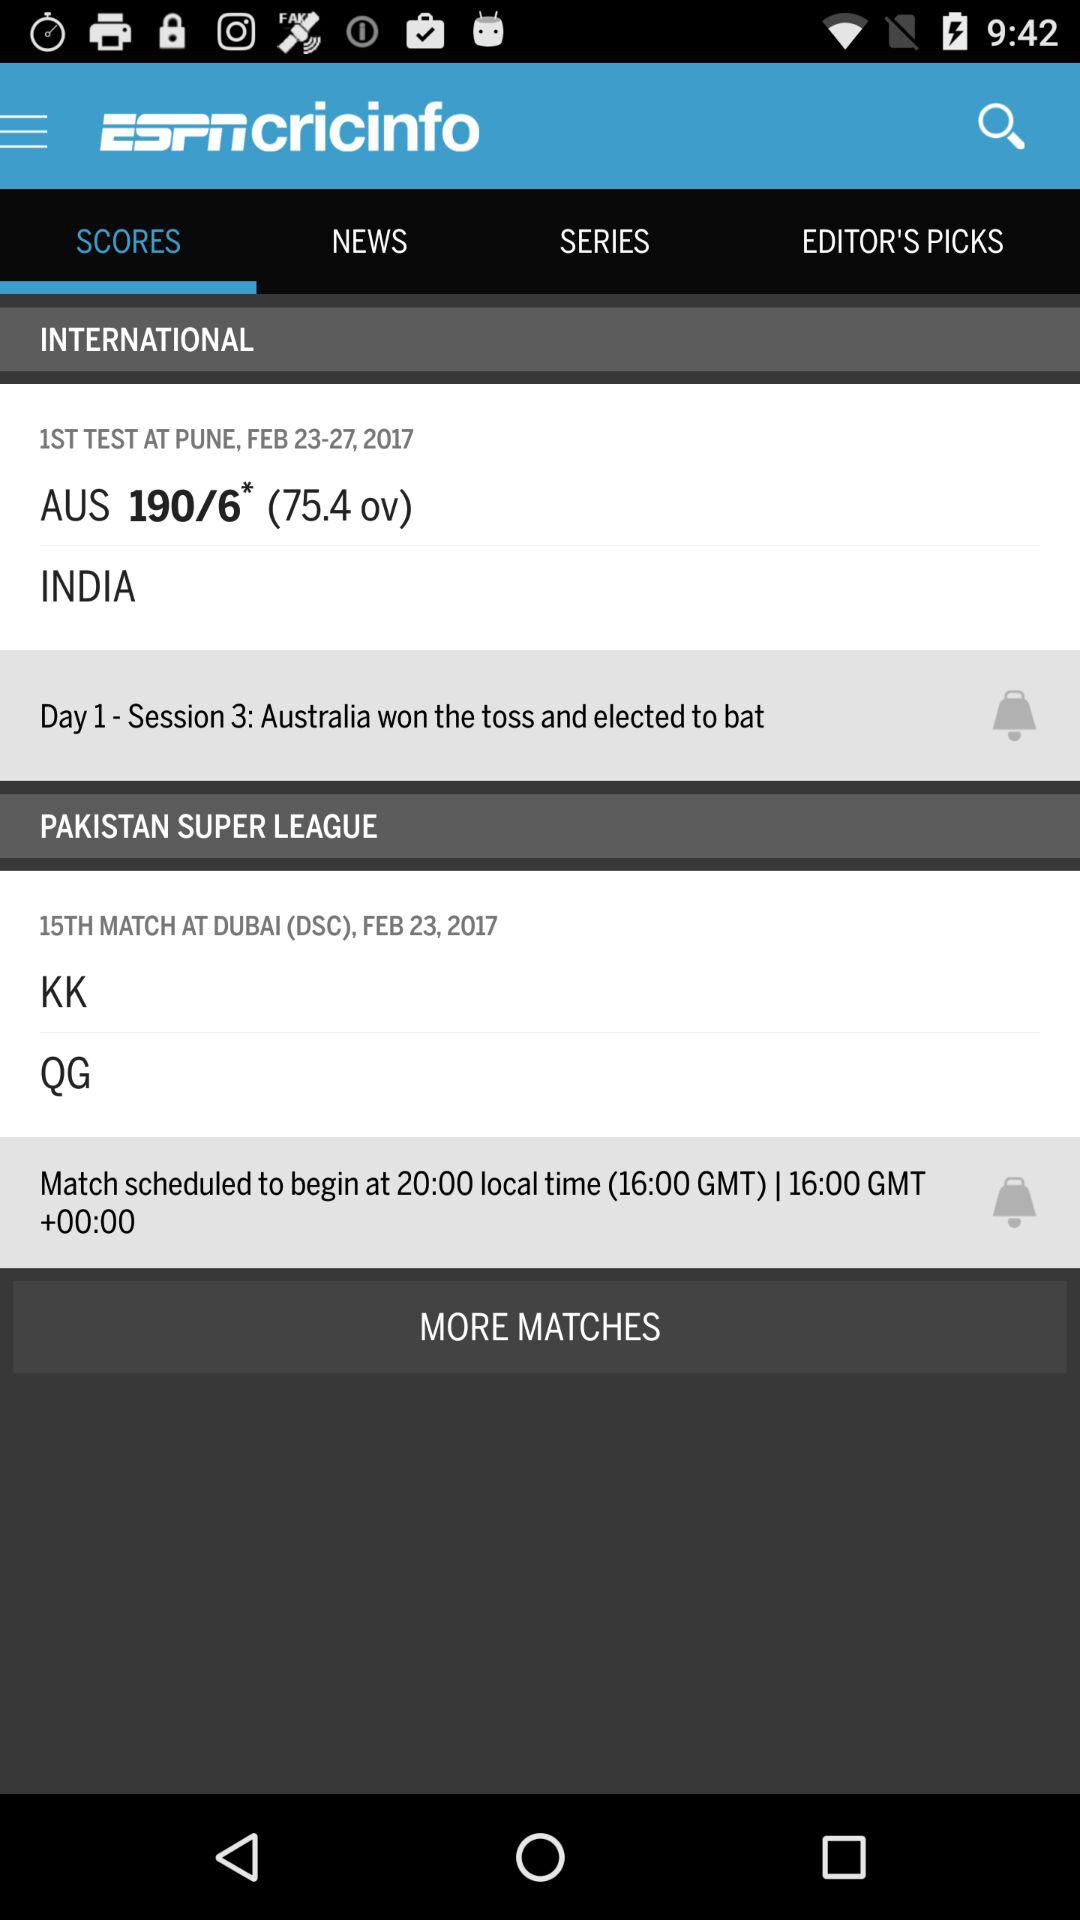What is the number of overs? The number of overs is 75.4. 